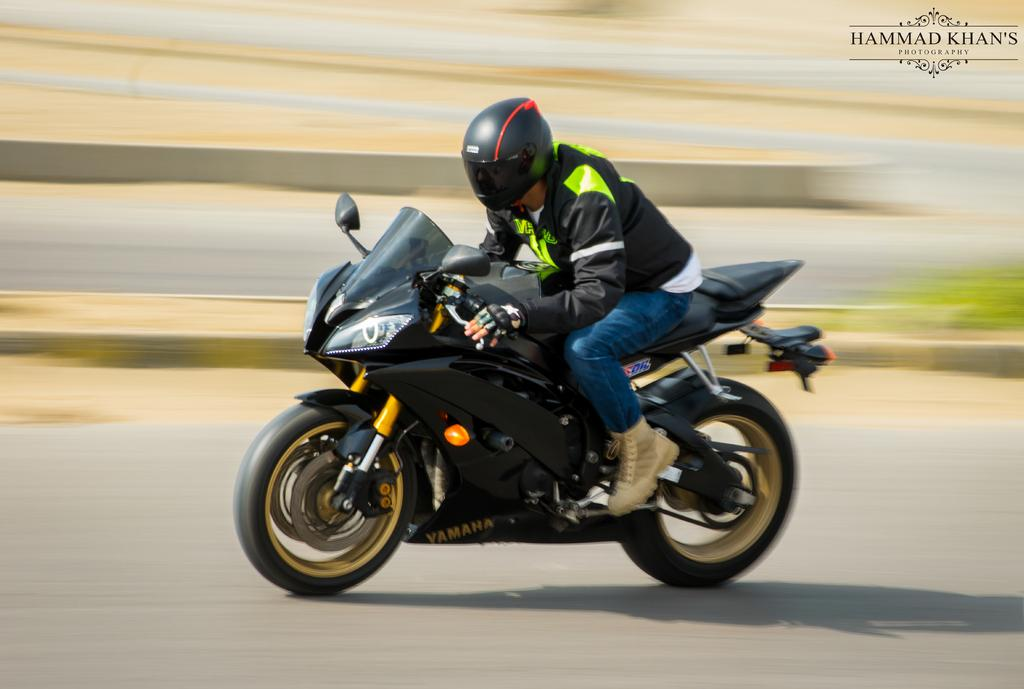Who is the person in the image? There is a man in the image. What is the man doing in the image? The man is riding a bike. Can you describe the movement of the bike in the image? The bike is in motion. What type of humor can be seen in the image? There is no humor present in the image; it simply shows a man riding a bike. 